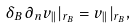<formula> <loc_0><loc_0><loc_500><loc_500>\delta _ { B } \, \partial _ { n } v _ { \| } | _ { { r } _ { B } } = v _ { \| } | _ { { r } _ { B } } ,</formula> 